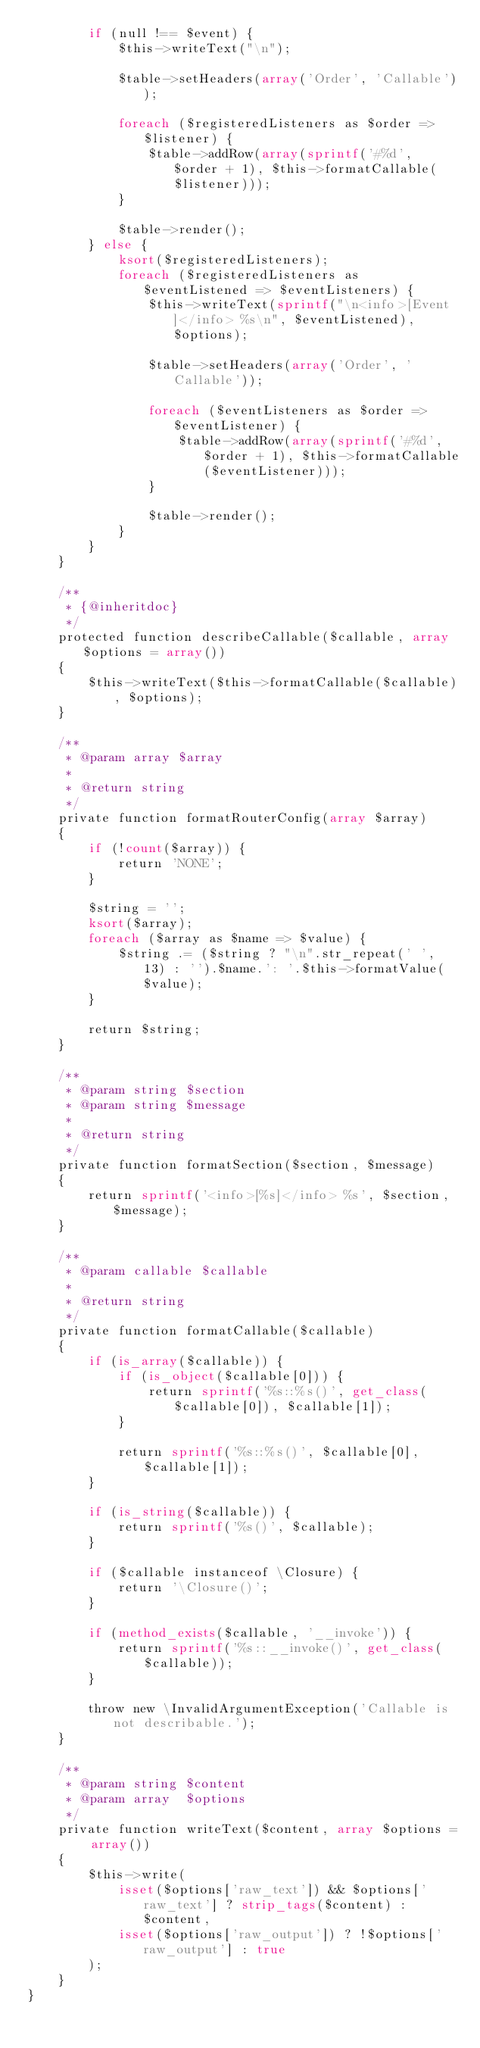<code> <loc_0><loc_0><loc_500><loc_500><_PHP_>        if (null !== $event) {
            $this->writeText("\n");

            $table->setHeaders(array('Order', 'Callable'));

            foreach ($registeredListeners as $order => $listener) {
                $table->addRow(array(sprintf('#%d', $order + 1), $this->formatCallable($listener)));
            }

            $table->render();
        } else {
            ksort($registeredListeners);
            foreach ($registeredListeners as $eventListened => $eventListeners) {
                $this->writeText(sprintf("\n<info>[Event]</info> %s\n", $eventListened), $options);

                $table->setHeaders(array('Order', 'Callable'));

                foreach ($eventListeners as $order => $eventListener) {
                    $table->addRow(array(sprintf('#%d', $order + 1), $this->formatCallable($eventListener)));
                }

                $table->render();
            }
        }
    }

    /**
     * {@inheritdoc}
     */
    protected function describeCallable($callable, array $options = array())
    {
        $this->writeText($this->formatCallable($callable), $options);
    }

    /**
     * @param array $array
     *
     * @return string
     */
    private function formatRouterConfig(array $array)
    {
        if (!count($array)) {
            return 'NONE';
        }

        $string = '';
        ksort($array);
        foreach ($array as $name => $value) {
            $string .= ($string ? "\n".str_repeat(' ', 13) : '').$name.': '.$this->formatValue($value);
        }

        return $string;
    }

    /**
     * @param string $section
     * @param string $message
     *
     * @return string
     */
    private function formatSection($section, $message)
    {
        return sprintf('<info>[%s]</info> %s', $section, $message);
    }

    /**
     * @param callable $callable
     *
     * @return string
     */
    private function formatCallable($callable)
    {
        if (is_array($callable)) {
            if (is_object($callable[0])) {
                return sprintf('%s::%s()', get_class($callable[0]), $callable[1]);
            }

            return sprintf('%s::%s()', $callable[0], $callable[1]);
        }

        if (is_string($callable)) {
            return sprintf('%s()', $callable);
        }

        if ($callable instanceof \Closure) {
            return '\Closure()';
        }

        if (method_exists($callable, '__invoke')) {
            return sprintf('%s::__invoke()', get_class($callable));
        }

        throw new \InvalidArgumentException('Callable is not describable.');
    }

    /**
     * @param string $content
     * @param array  $options
     */
    private function writeText($content, array $options = array())
    {
        $this->write(
            isset($options['raw_text']) && $options['raw_text'] ? strip_tags($content) : $content,
            isset($options['raw_output']) ? !$options['raw_output'] : true
        );
    }
}
</code> 